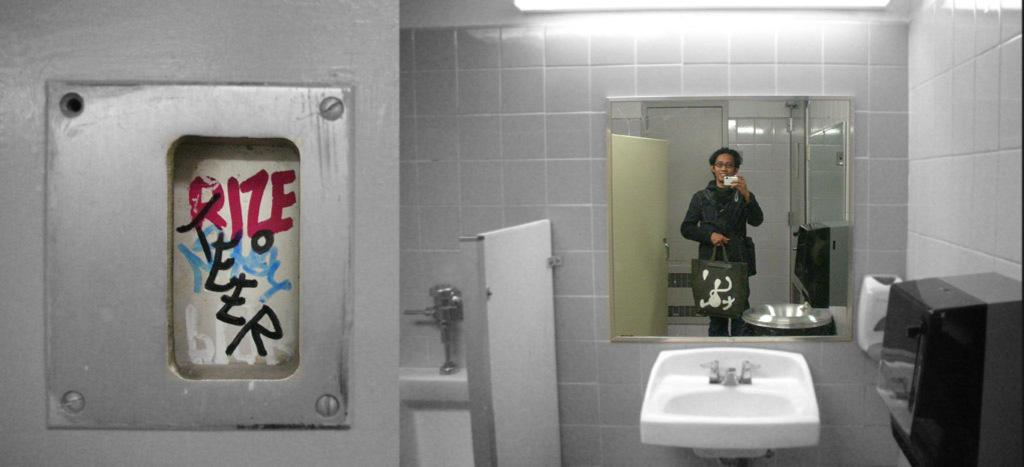Could you give a brief overview of what you see in this image? This picture was taken in the washroom. This is the washbasin with the taps. I can see a black color object, which is attached to the wall. In the mirror, I can see the reflection of the man standing and holding a bag and a mobile phone in his hands. This looks like a flush tank. I can see a metal object attached to the wall. This is the tube light. These are the tiles. 